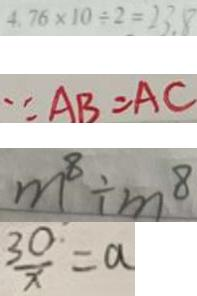Convert formula to latex. <formula><loc_0><loc_0><loc_500><loc_500>4 . 7 6 \times 1 0 \div 2 = 2 3 . 8 
 \because A B = A C 
 m ^ { 8 } \div m ^ { 8 } 
 \frac { 3 0 } { x } = a</formula> 